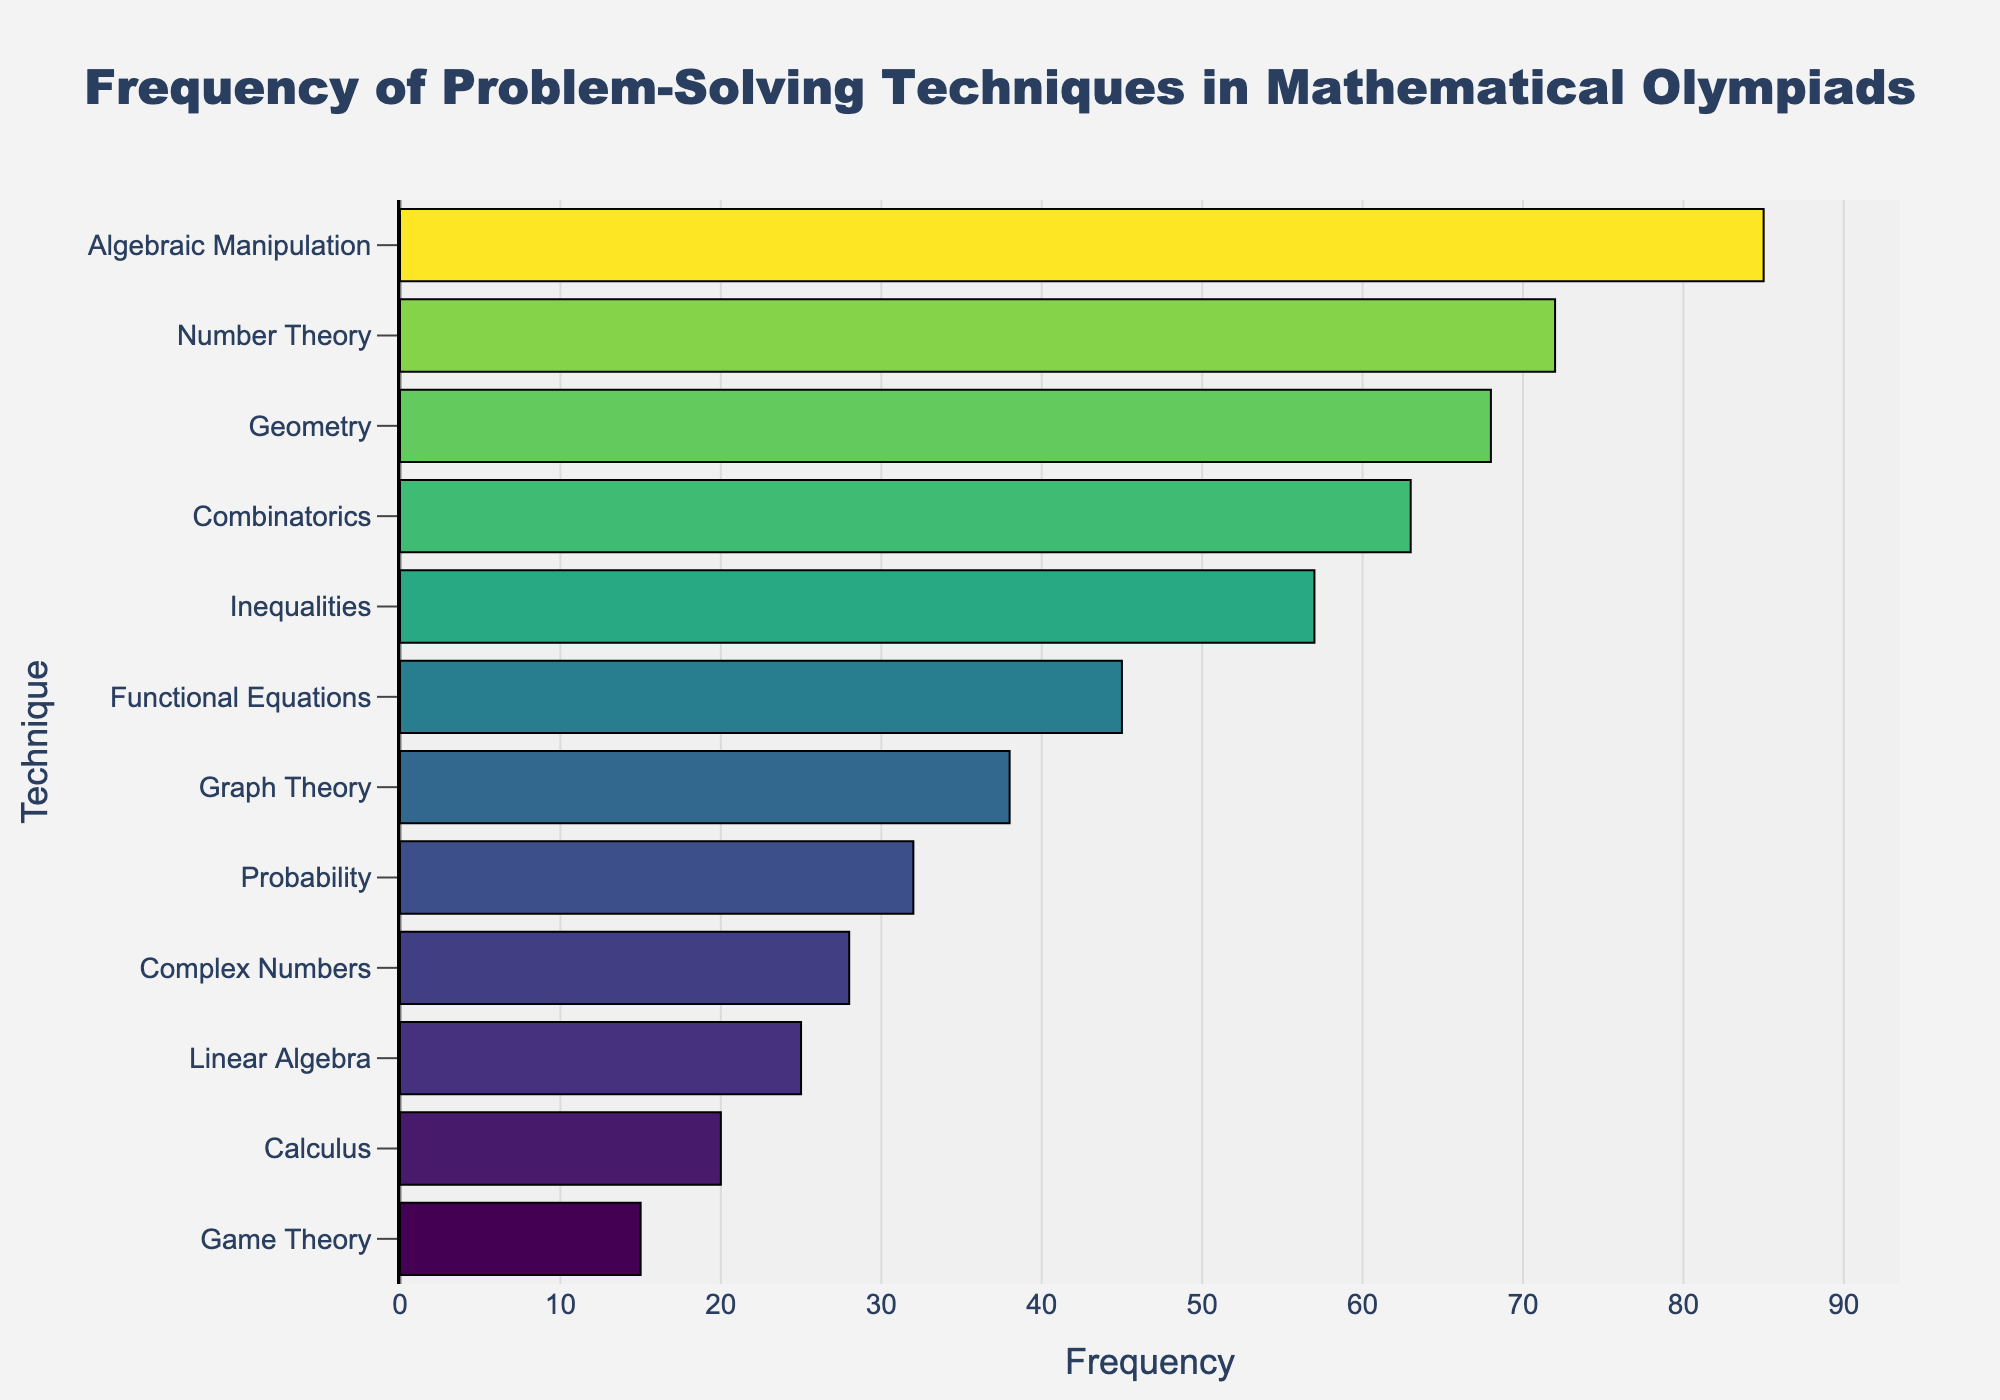What's the title of the plot? To identify the title, look at the top of the plot where the title text is usually located.
Answer: Frequency of Problem-Solving Techniques in Mathematical Olympiads Which technique has the highest frequency? To determine this, locate the longest bar on the horizontal plot and read the corresponding technique name on the y-axis.
Answer: Algebraic Manipulation How many techniques are listed in the plot? To find this, count the number of different labels on the y-axis.
Answer: 12 What is the combined frequency of Functional Equations and Graph Theory? Look at the frequencies for Functional Equations (45) and Graph Theory (38) and sum them up: 45 + 38 = 83.
Answer: 83 Which technique has a frequency of 72? Find the bar with a frequency of 72 and read the corresponding technique name on the y-axis.
Answer: Number Theory How does the frequency of Combinatorics compare to Calculus? Find the lengths of the bars corresponding to Combinatorics (63) and Calculus (20), then compare them.
Answer: Combinatorics is more frequent than Calculus What is the average frequency of all the techniques? Add all the frequencies and divide by the total number of techniques: (85 + 72 + 68 + 63 + 57 + 45 + 38 + 32 + 28 + 25 + 20 + 15) / 12 = 47
Answer: 47 Which techniques have a frequency greater than 60? Identify bars longer than 60 units and read the technique names on the y-axis. These are Algebraic Manipulation (85), Number Theory (72), Geometry (68), and Combinatorics (63).
Answer: Algebraic Manipulation, Number Theory, Geometry, Combinatorics What color represents the highest frequency? Examine the color gradient and identify the color at the end of the highest frequency bar (Algebraic Manipulation).
Answer: Darker shade of the Viridis colorscale By how much does the frequency of Algebraic Manipulation exceed that of Probability? Subtract the frequency of Probability (32) from that of Algebraic Manipulation (85): 85 - 32 = 53.
Answer: 53 